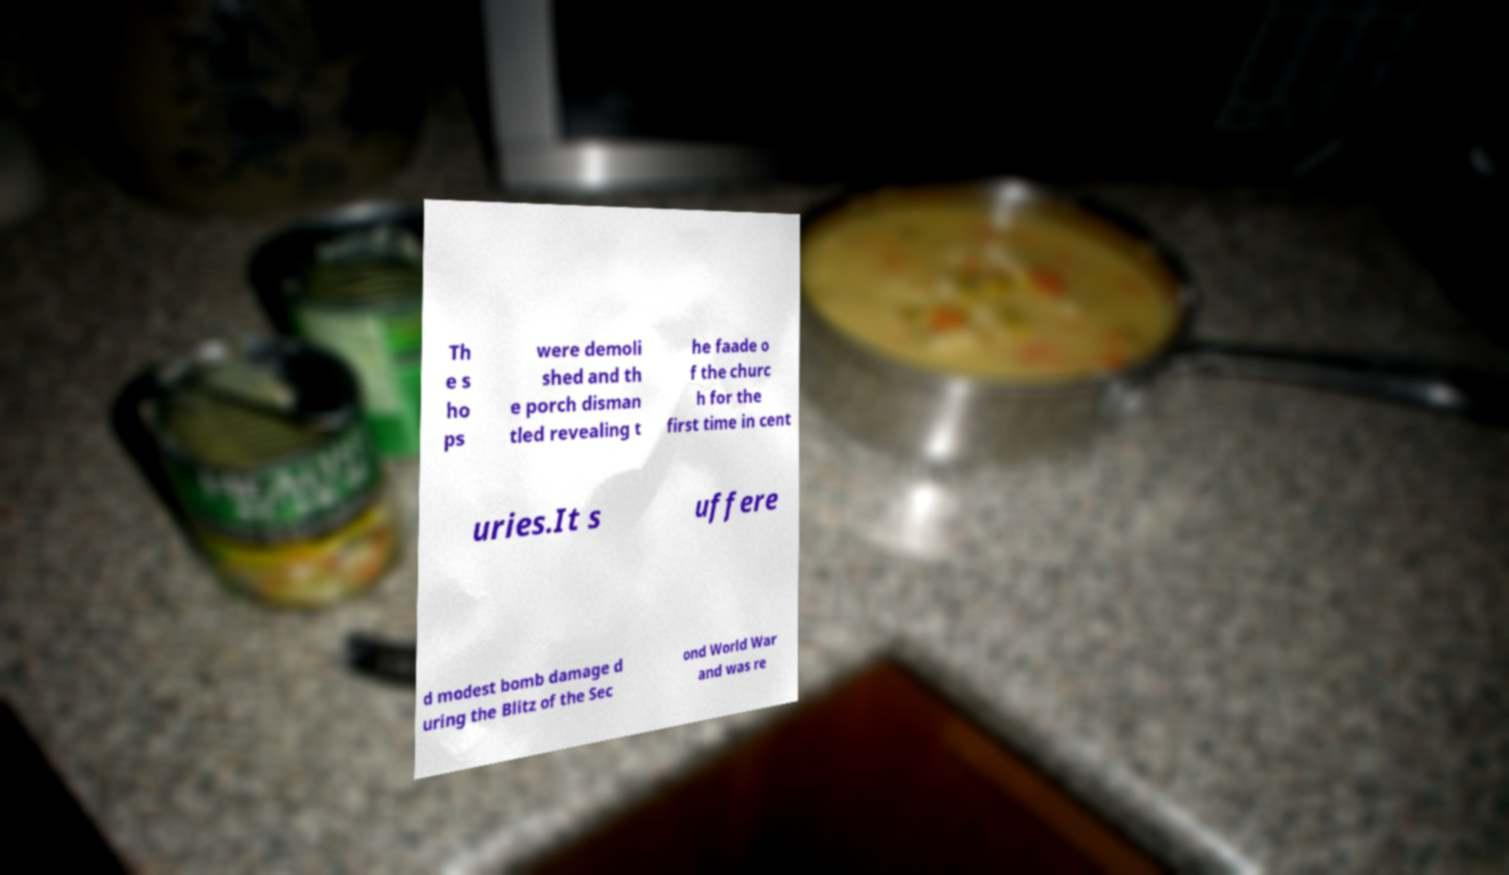Can you read and provide the text displayed in the image?This photo seems to have some interesting text. Can you extract and type it out for me? Th e s ho ps were demoli shed and th e porch disman tled revealing t he faade o f the churc h for the first time in cent uries.It s uffere d modest bomb damage d uring the Blitz of the Sec ond World War and was re 